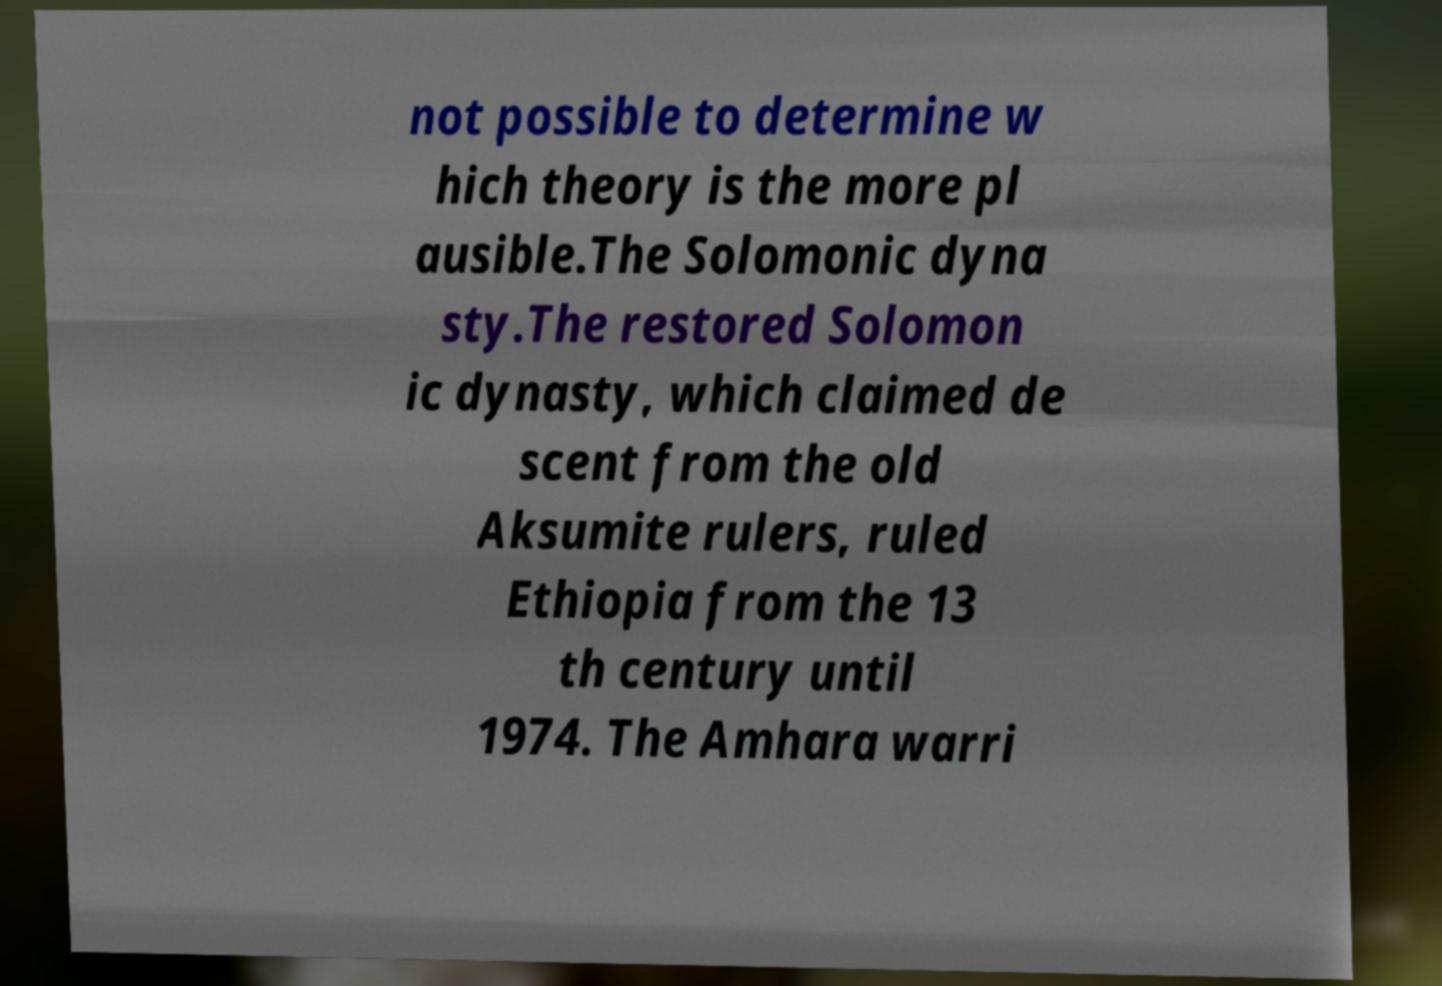Could you extract and type out the text from this image? not possible to determine w hich theory is the more pl ausible.The Solomonic dyna sty.The restored Solomon ic dynasty, which claimed de scent from the old Aksumite rulers, ruled Ethiopia from the 13 th century until 1974. The Amhara warri 